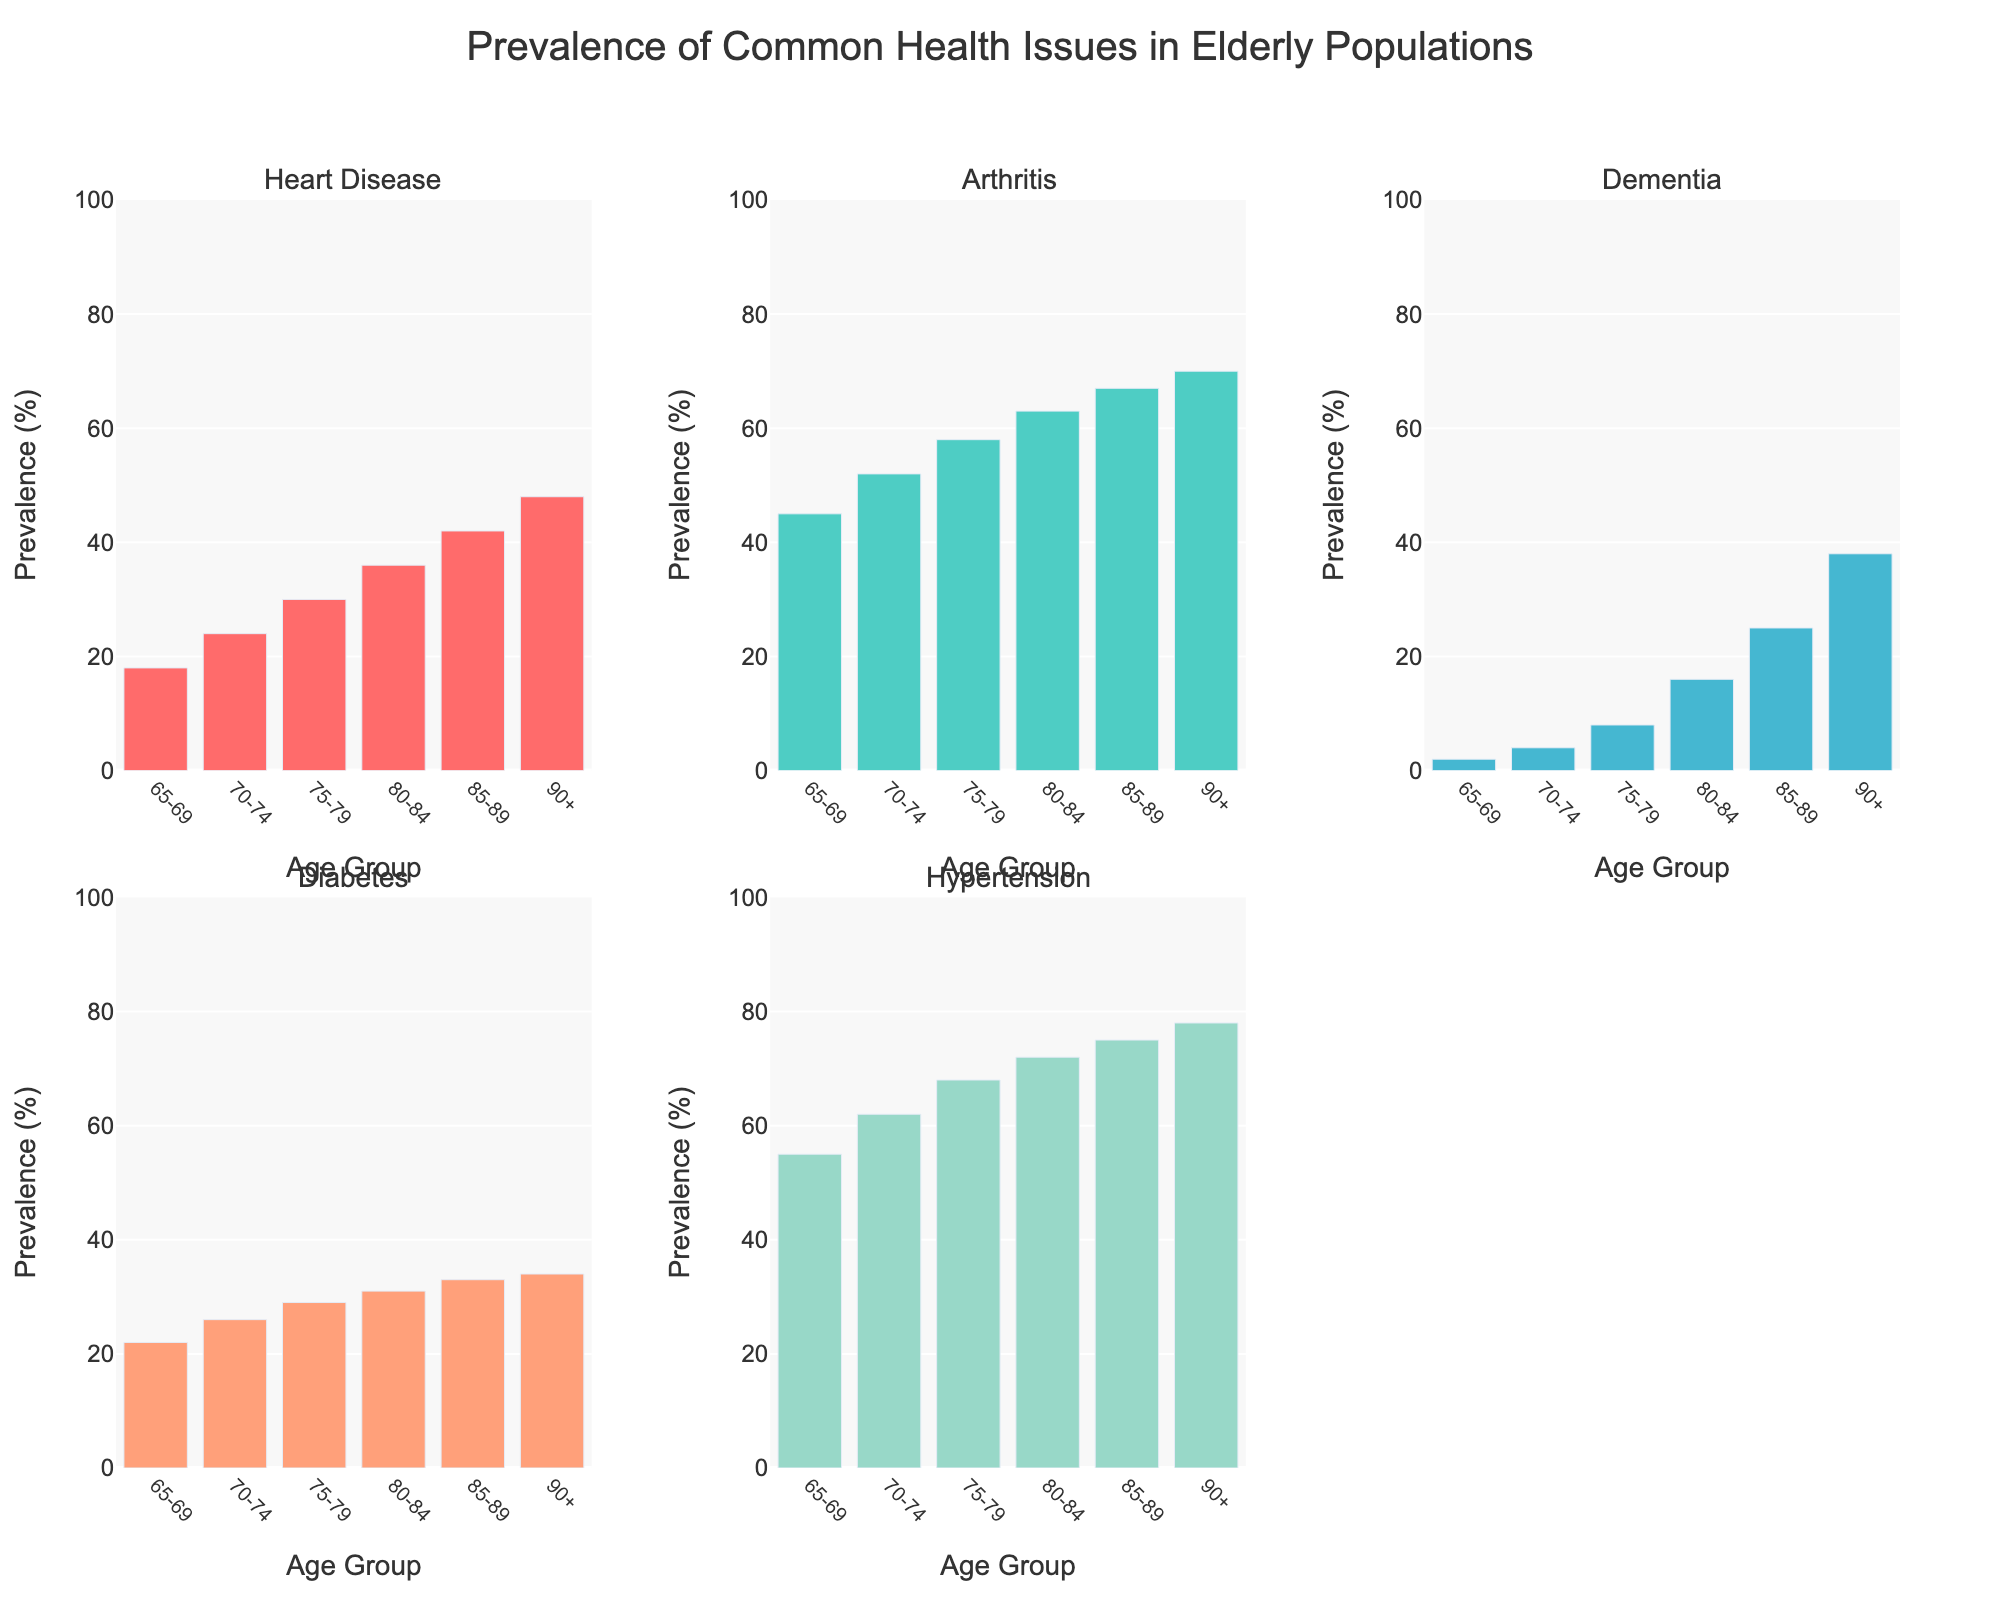Which age group has the highest prevalence of heart disease? By visually inspecting the subplots for heart disease, observe which bar is the tallest among all age groups. The tallest bar corresponds to the 90+ age group.
Answer: 90+ What is the difference in arthritis prevalence between the 70-74 and 80-84 age groups? Look at the subplots for arthritis and note the heights of the bars for the 70-74 and 80-84 age groups, which are 52% and 63% respectively. Calculate the difference: 63% - 52% = 11%.
Answer: 11% Which health issue increases most drastically between the 65-69 and 90+ age groups? Compare the bars in each subplot from the 65-69 age group to the 90+ age group. Dementia prevalence has the biggest increase from 2% to 38%.
Answer: Dementia How does the prevalence of hypertension change across the age groups? Observe the subplot for hypertension to see how the bars gradually increase from 55% in the 65-69 age group to 78% in the 90+ age group.
Answer: Increases Which age group has the lowest prevalence of diabetes? Inspect the subplot for diabetes and find the shortest bar. The shortest bar corresponds to the 65-69 age group at 22%.
Answer: 65-69 What is the average prevalence of dementia across all age groups? Add the prevalence values for dementia across all age groups (2 + 4 + 8 + 16 + 25 + 38 = 93) and divide by the number of age groups (6). So, 93/6 = 15.5%.
Answer: 15.5% Is the prevalence of heart disease higher in the 75-79 or 85-89 age group? Compare the bars for heart disease in the 75-79 and 85-89 age groups. The values are 30% and 42% respectively, so heart disease is higher in the 85-89 age group.
Answer: 85-89 What is the total prevalence of hypertension and diabetes for the 80-84 age group? Add the prevalence values of hypertension and diabetes for the 80-84 age group, which are 72% and 31% respectively. So, 72 + 31 = 103%.
Answer: 103% Between which two consecutive age groups does arthritis prevalence see the smallest increase? Check the increase in arthritis prevalence between consecutive age groups: 7% (65-69 to 70-74), 6% (70-74 to 75-79), 5% (75-79 to 80-84), 4% (80-84 to 85-89), 3% (85-89 to 90+). The smallest increase is 3% between 85-89 and 90+.
Answer: 85-89 to 90+ Does the prevalence of any health issue reach or exceed 50% in the 65-69 age group? View the bars for the 65-69 age group in each subplot. Hypertension is the only health issue above 50% (55%).
Answer: Yes, hypertension 